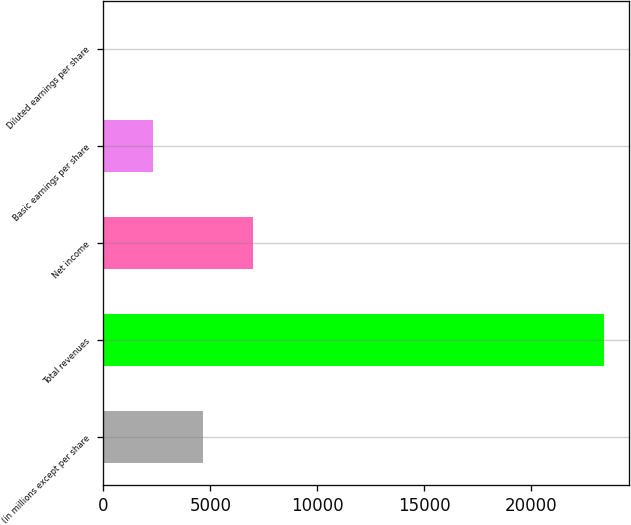<chart> <loc_0><loc_0><loc_500><loc_500><bar_chart><fcel>(in millions except per share<fcel>Total revenues<fcel>Net income<fcel>Basic earnings per share<fcel>Diluted earnings per share<nl><fcel>4675.07<fcel>23371<fcel>7012.06<fcel>2338.08<fcel>1.09<nl></chart> 